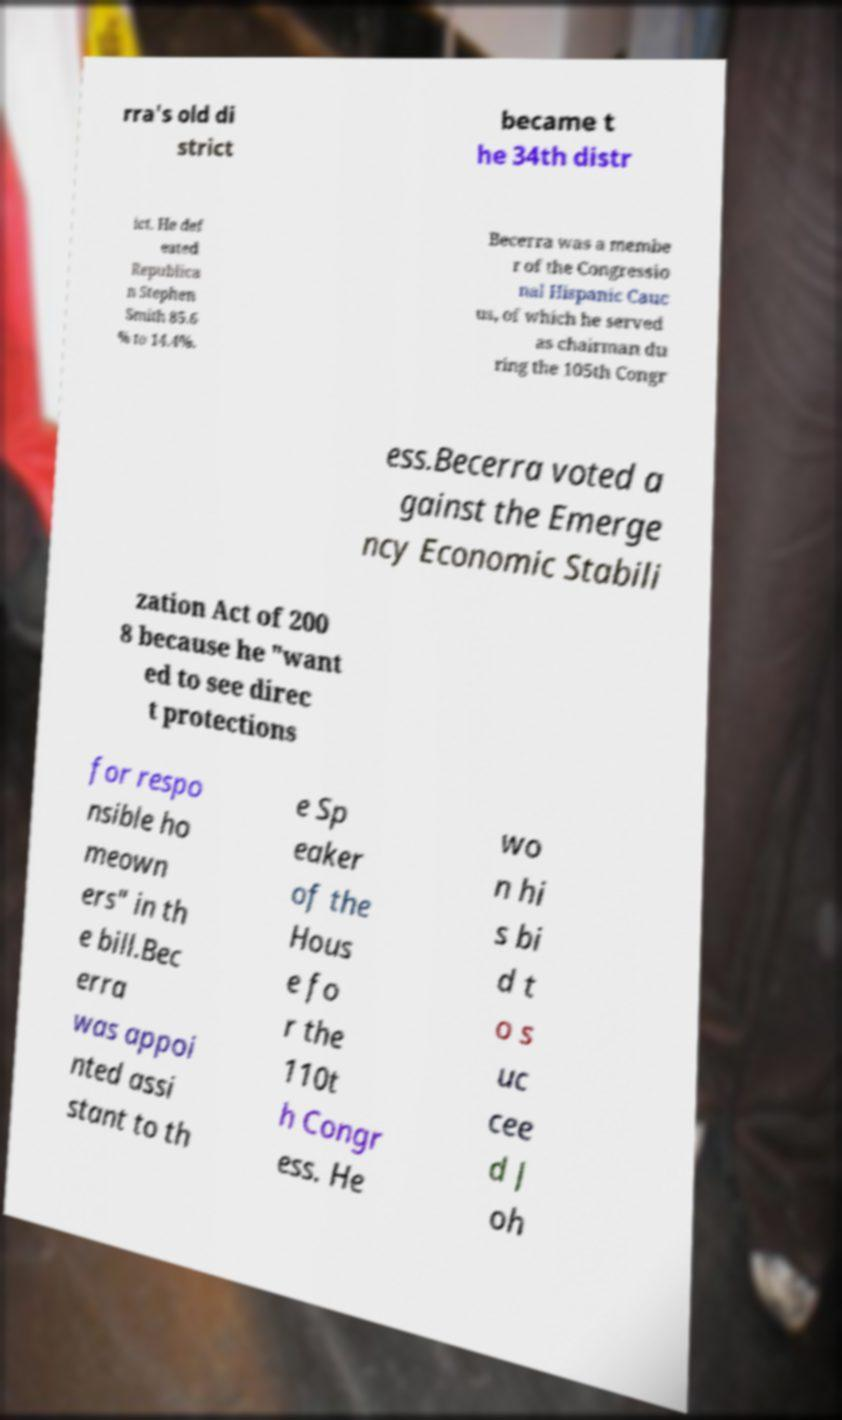Please read and relay the text visible in this image. What does it say? rra's old di strict became t he 34th distr ict. He def eated Republica n Stephen Smith 85.6 % to 14.4%. Becerra was a membe r of the Congressio nal Hispanic Cauc us, of which he served as chairman du ring the 105th Congr ess.Becerra voted a gainst the Emerge ncy Economic Stabili zation Act of 200 8 because he "want ed to see direc t protections for respo nsible ho meown ers" in th e bill.Bec erra was appoi nted assi stant to th e Sp eaker of the Hous e fo r the 110t h Congr ess. He wo n hi s bi d t o s uc cee d J oh 